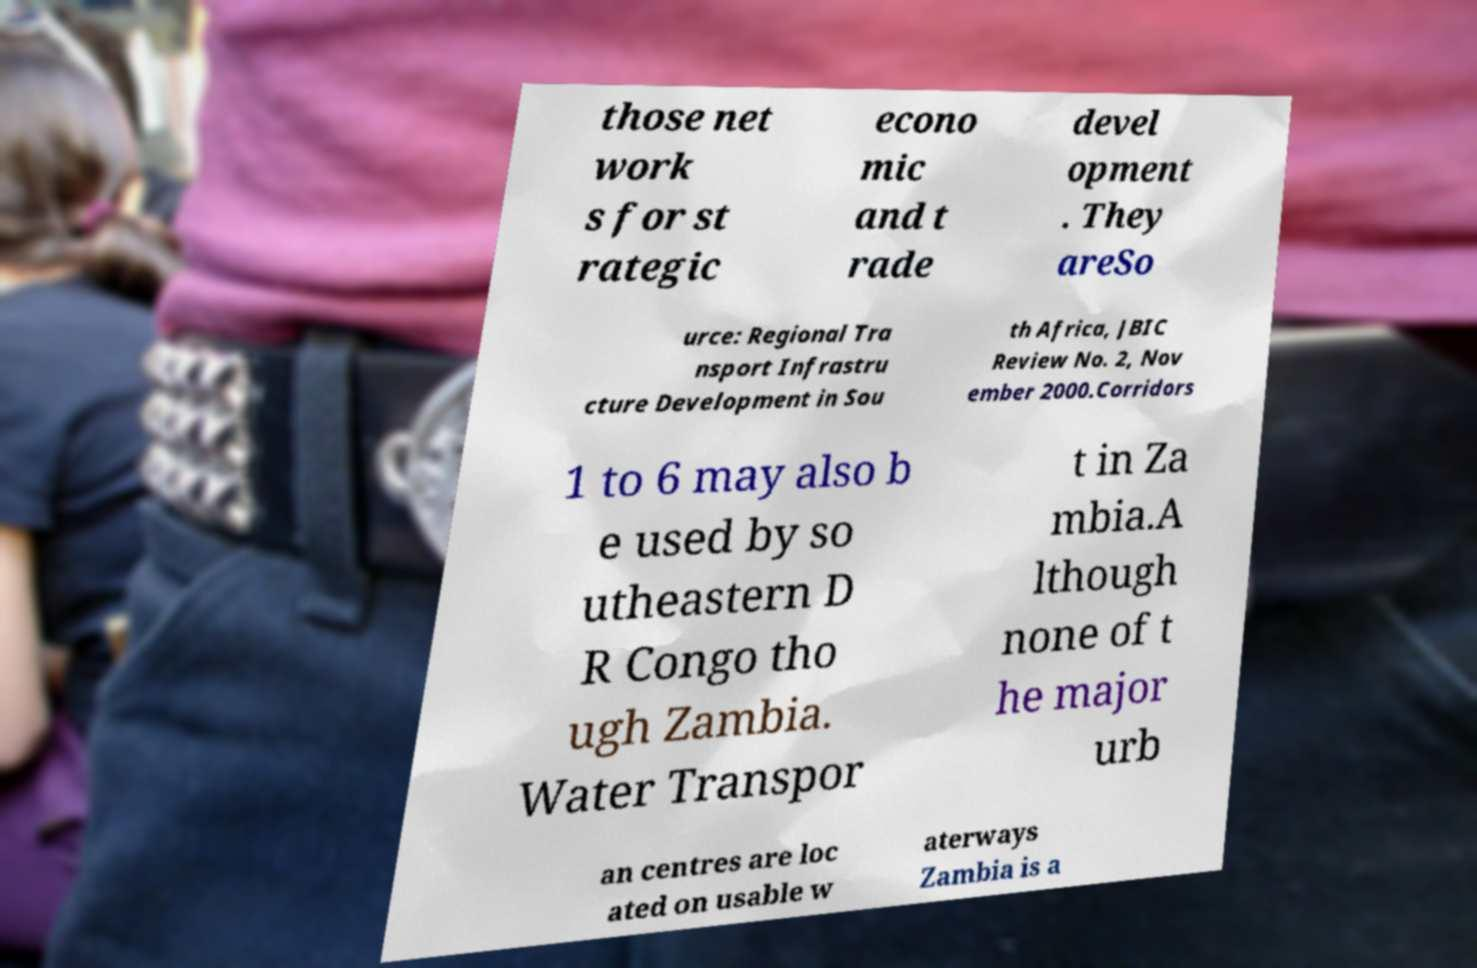What messages or text are displayed in this image? I need them in a readable, typed format. those net work s for st rategic econo mic and t rade devel opment . They areSo urce: Regional Tra nsport Infrastru cture Development in Sou th Africa, JBIC Review No. 2, Nov ember 2000.Corridors 1 to 6 may also b e used by so utheastern D R Congo tho ugh Zambia. Water Transpor t in Za mbia.A lthough none of t he major urb an centres are loc ated on usable w aterways Zambia is a 